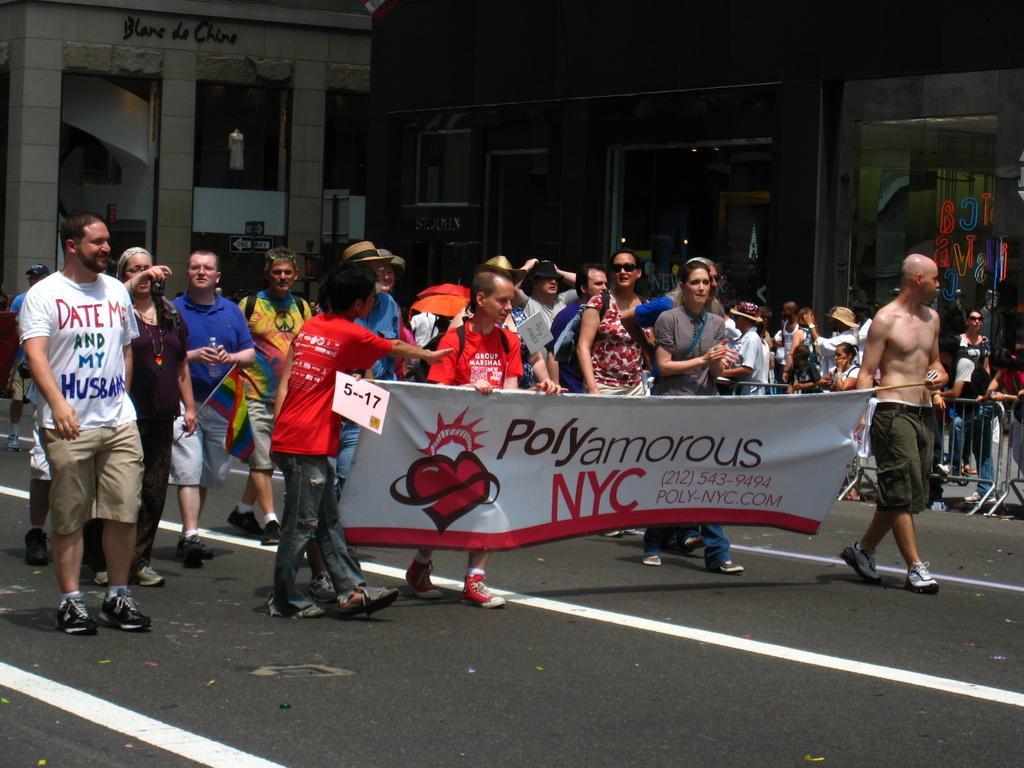In one or two sentences, can you explain what this image depicts? In this picture there are two persons holding a banner which has something written on it and there are few other persons standing behind them and there are buildings in the background. 